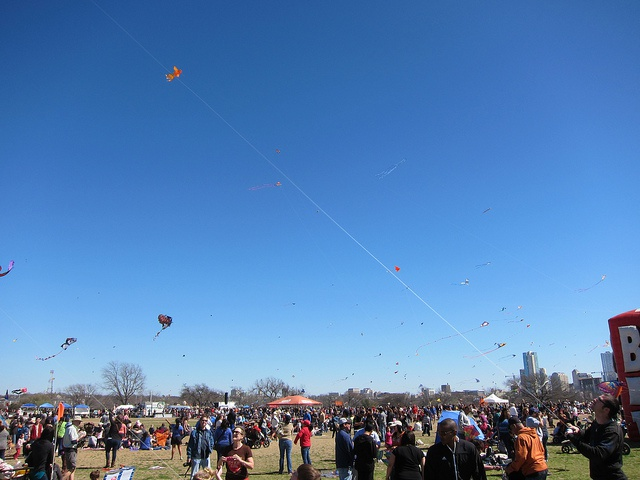Describe the objects in this image and their specific colors. I can see kite in darkblue, lightblue, and gray tones, people in darkblue, black, gray, tan, and maroon tones, people in darkblue, black, maroon, salmon, and brown tones, people in darkblue, black, gray, and darkgreen tones, and people in darkblue, black, maroon, brown, and lightpink tones in this image. 